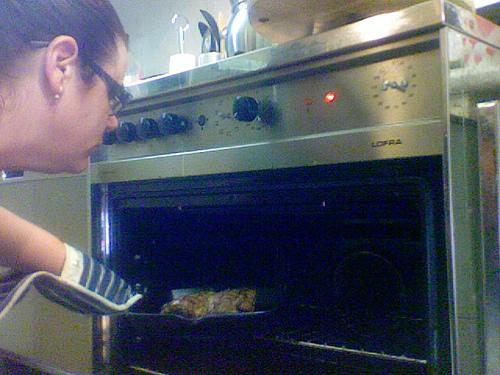Is there a light on the oven?
Answer briefly. Yes. Does the woman have perfect eyesight?
Answer briefly. No. Are they wearing an oven mitt?
Write a very short answer. Yes. 